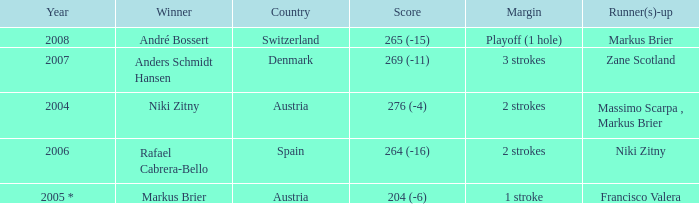In what year was the score 204 (-6)? 2005 *. 